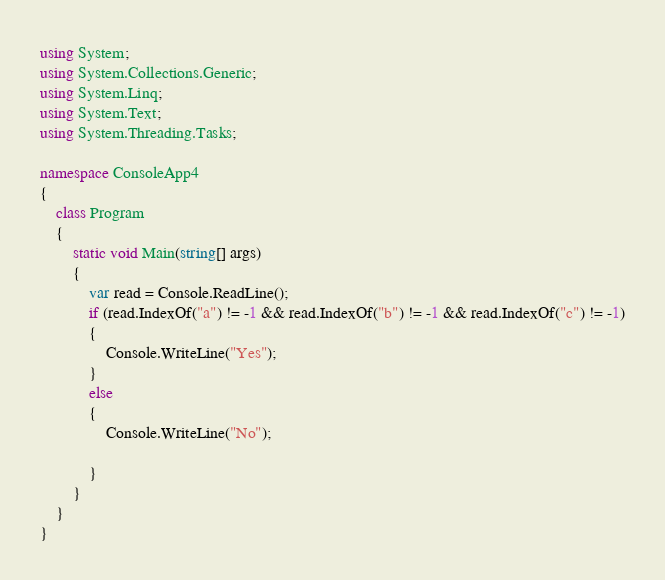<code> <loc_0><loc_0><loc_500><loc_500><_C#_>using System;
using System.Collections.Generic;
using System.Linq;
using System.Text;
using System.Threading.Tasks;

namespace ConsoleApp4
{
    class Program
    {
        static void Main(string[] args)
        {
            var read = Console.ReadLine();
            if (read.IndexOf("a") != -1 && read.IndexOf("b") != -1 && read.IndexOf("c") != -1)
            {
                Console.WriteLine("Yes");
            }
            else
            {
                Console.WriteLine("No");

            }
        }
    }
}
</code> 